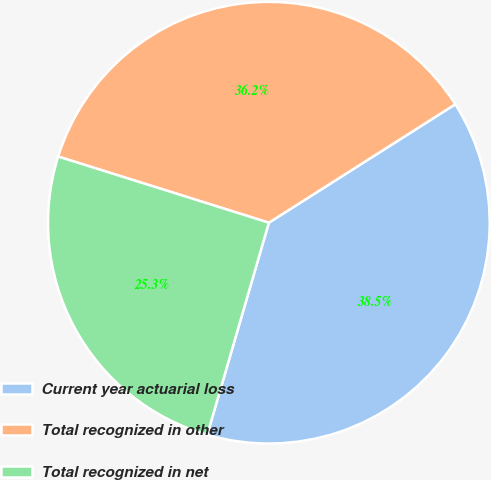Convert chart to OTSL. <chart><loc_0><loc_0><loc_500><loc_500><pie_chart><fcel>Current year actuarial loss<fcel>Total recognized in other<fcel>Total recognized in net<nl><fcel>38.51%<fcel>36.15%<fcel>25.34%<nl></chart> 